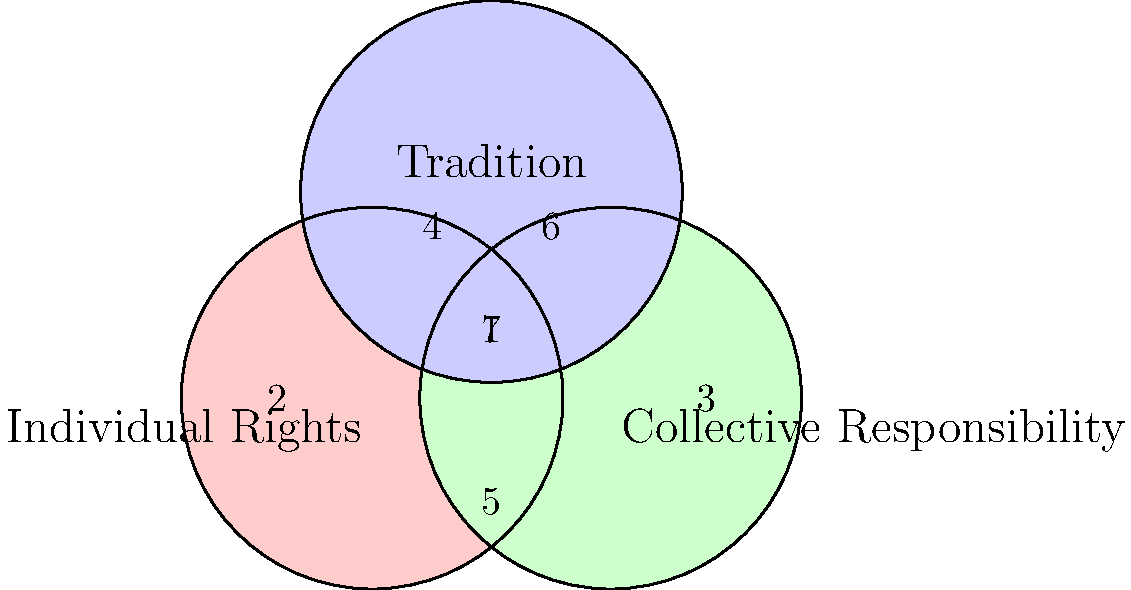In the Venn diagram above, three cultural values are represented: Individual Rights, Collective Responsibility, and Tradition. Considering the philosophical implications of oversimplification in sociocultural comparisons, which region(s) might represent a society that balances all three values equally, and what challenges might arise from this representation? To answer this question, we need to consider the following steps:

1. Understand the diagram:
   - Each circle represents a cultural value.
   - Overlapping regions represent areas where values intersect.

2. Identify the region representing equal balance:
   - Region 7, at the center where all three circles overlap, represents a society that balances all three values equally.

3. Consider the philosophical implications:
   a) Oversimplification:
      - The Venn diagram presents a simplified view of complex cultural values.
      - It assumes these values can be clearly delineated and measured.

   b) Equal balance challenges:
      - The diagram suggests a perfect balance is possible, which may not reflect reality.
      - It doesn't account for the intensity or priority of each value within the overlapping region.

   c) Context and interpretation:
      - The meaning of each value may vary across cultures, making direct comparisons problematic.
      - The diagram doesn't show how these values interact or potentially conflict.

   d) Dynamic nature of culture:
      - The static representation doesn't capture the evolving nature of cultural values over time.

   e) Reductionism:
      - Reducing complex sociocultural systems to three broad categories risks overlooking nuances and subcultures.

4. Challenges of this representation:
   - It may lead to oversimplified policy-making or cultural analysis.
   - It could promote a false sense of universalism in value systems.
   - It might encourage stereotyping or overgeneralization of cultures.
   - The representation lacks the ability to show the strength or weakness of each value's influence.

In conclusion, while region 7 represents a theoretical balance of all three values, the philosophical implications of using such a simplified model for sociocultural comparisons are significant and potentially problematic.
Answer: Region 7; oversimplification, false equivalence, lack of context, static representation, and reductionism. 